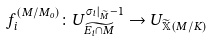<formula> <loc_0><loc_0><loc_500><loc_500>f _ { i } ^ { ( M / M _ { o } ) } \colon U _ { \widetilde { E _ { i } \cap M } } ^ { \sigma _ { i } | _ { \widetilde { M } } - 1 } \rightarrow U _ { \widetilde { \mathbb { X } } ( M / K ) }</formula> 